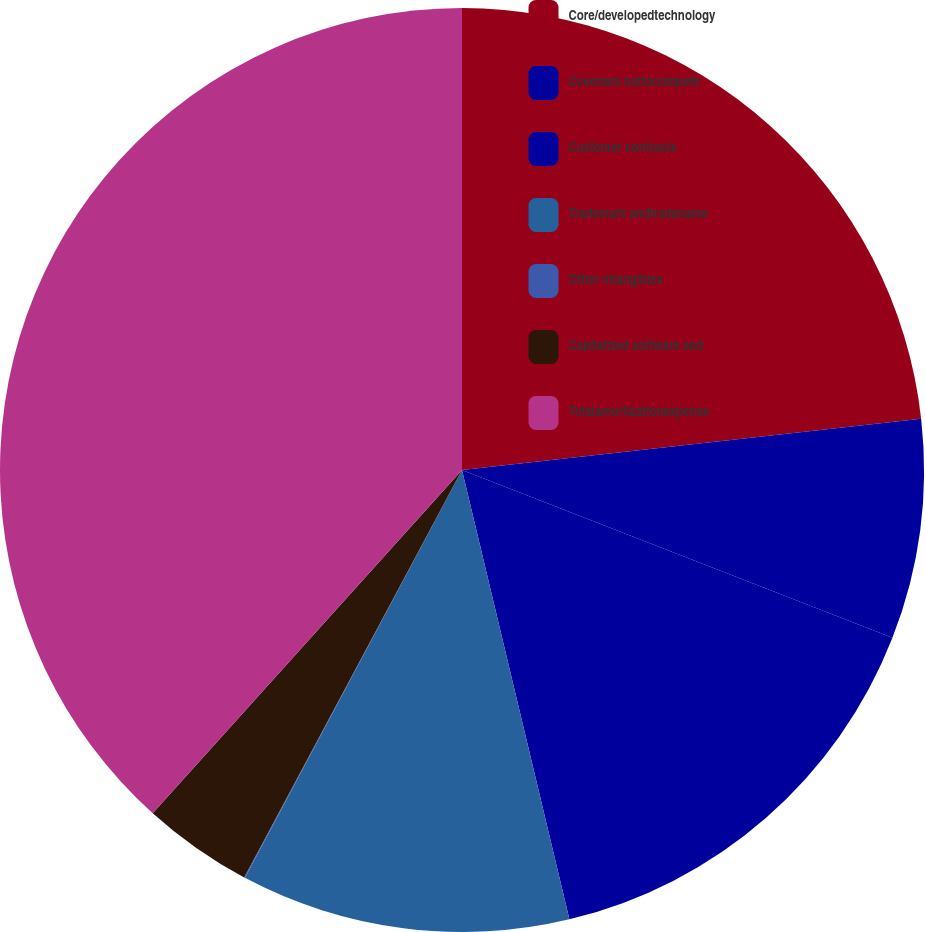<chart> <loc_0><loc_0><loc_500><loc_500><pie_chart><fcel>Core/developedtechnology<fcel>Covenant nottocompete<fcel>Customer contracts<fcel>Trademark andtradename<fcel>Other intangibles<fcel>Capitalized software and<fcel>Totalamortizationexpense<nl><fcel>23.23%<fcel>7.69%<fcel>15.35%<fcel>11.52%<fcel>0.03%<fcel>3.86%<fcel>38.33%<nl></chart> 